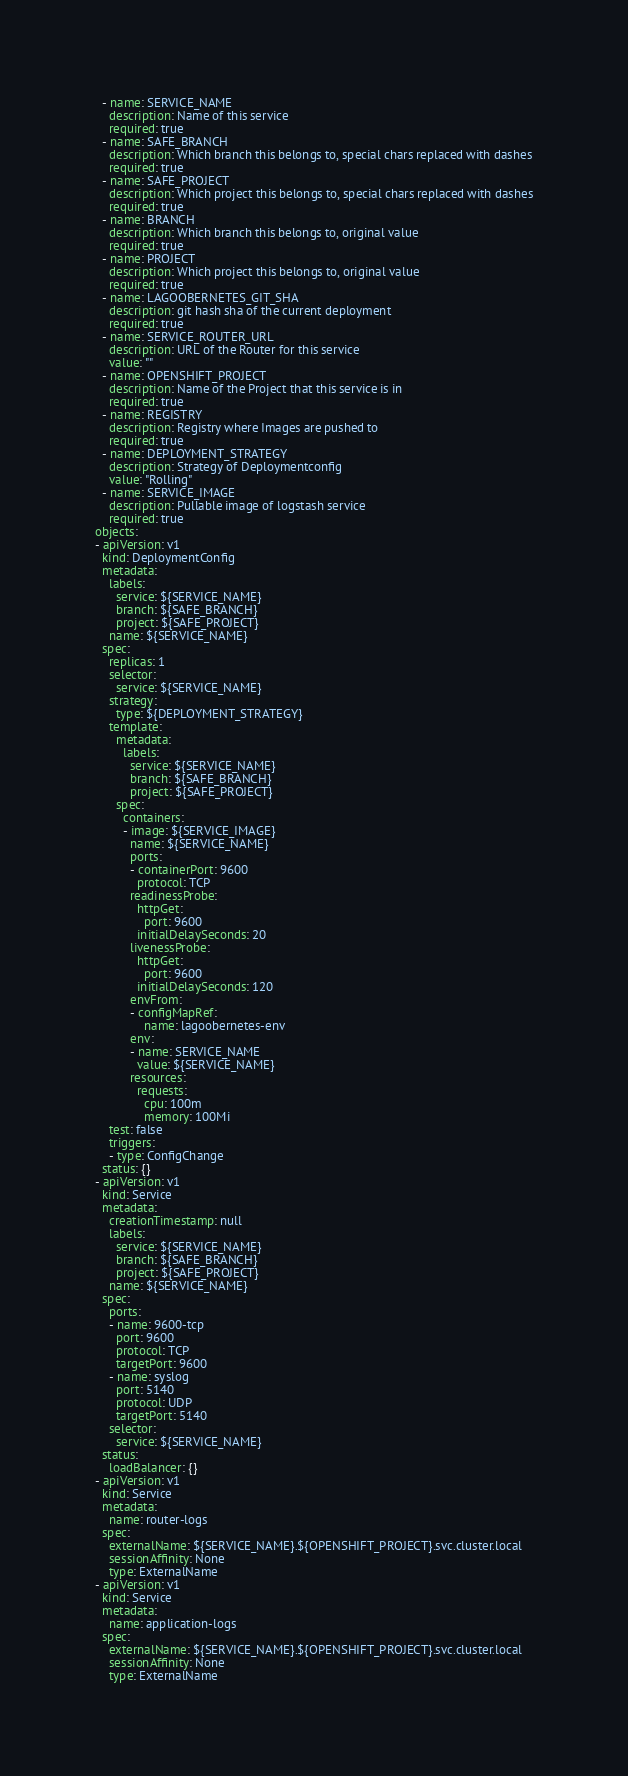Convert code to text. <code><loc_0><loc_0><loc_500><loc_500><_YAML_>  - name: SERVICE_NAME
    description: Name of this service
    required: true
  - name: SAFE_BRANCH
    description: Which branch this belongs to, special chars replaced with dashes
    required: true
  - name: SAFE_PROJECT
    description: Which project this belongs to, special chars replaced with dashes
    required: true
  - name: BRANCH
    description: Which branch this belongs to, original value
    required: true
  - name: PROJECT
    description: Which project this belongs to, original value
    required: true
  - name: LAGOOBERNETES_GIT_SHA
    description: git hash sha of the current deployment
    required: true
  - name: SERVICE_ROUTER_URL
    description: URL of the Router for this service
    value: ""
  - name: OPENSHIFT_PROJECT
    description: Name of the Project that this service is in
    required: true
  - name: REGISTRY
    description: Registry where Images are pushed to
    required: true
  - name: DEPLOYMENT_STRATEGY
    description: Strategy of Deploymentconfig
    value: "Rolling"
  - name: SERVICE_IMAGE
    description: Pullable image of logstash service
    required: true
objects:
- apiVersion: v1
  kind: DeploymentConfig
  metadata:
    labels:
      service: ${SERVICE_NAME}
      branch: ${SAFE_BRANCH}
      project: ${SAFE_PROJECT}
    name: ${SERVICE_NAME}
  spec:
    replicas: 1
    selector:
      service: ${SERVICE_NAME}
    strategy:
      type: ${DEPLOYMENT_STRATEGY}
    template:
      metadata:
        labels:
          service: ${SERVICE_NAME}
          branch: ${SAFE_BRANCH}
          project: ${SAFE_PROJECT}
      spec:
        containers:
        - image: ${SERVICE_IMAGE}
          name: ${SERVICE_NAME}
          ports:
          - containerPort: 9600
            protocol: TCP
          readinessProbe:
            httpGet:
              port: 9600
            initialDelaySeconds: 20
          livenessProbe:
            httpGet:
              port: 9600
            initialDelaySeconds: 120
          envFrom:
          - configMapRef:
              name: lagoobernetes-env
          env:
          - name: SERVICE_NAME
            value: ${SERVICE_NAME}
          resources:
            requests:
              cpu: 100m
              memory: 100Mi
    test: false
    triggers:
    - type: ConfigChange
  status: {}
- apiVersion: v1
  kind: Service
  metadata:
    creationTimestamp: null
    labels:
      service: ${SERVICE_NAME}
      branch: ${SAFE_BRANCH}
      project: ${SAFE_PROJECT}
    name: ${SERVICE_NAME}
  spec:
    ports:
    - name: 9600-tcp
      port: 9600
      protocol: TCP
      targetPort: 9600
    - name: syslog
      port: 5140
      protocol: UDP
      targetPort: 5140
    selector:
      service: ${SERVICE_NAME}
  status:
    loadBalancer: {}
- apiVersion: v1
  kind: Service
  metadata:
    name: router-logs
  spec:
    externalName: ${SERVICE_NAME}.${OPENSHIFT_PROJECT}.svc.cluster.local
    sessionAffinity: None
    type: ExternalName
- apiVersion: v1
  kind: Service
  metadata:
    name: application-logs
  spec:
    externalName: ${SERVICE_NAME}.${OPENSHIFT_PROJECT}.svc.cluster.local
    sessionAffinity: None
    type: ExternalName
</code> 